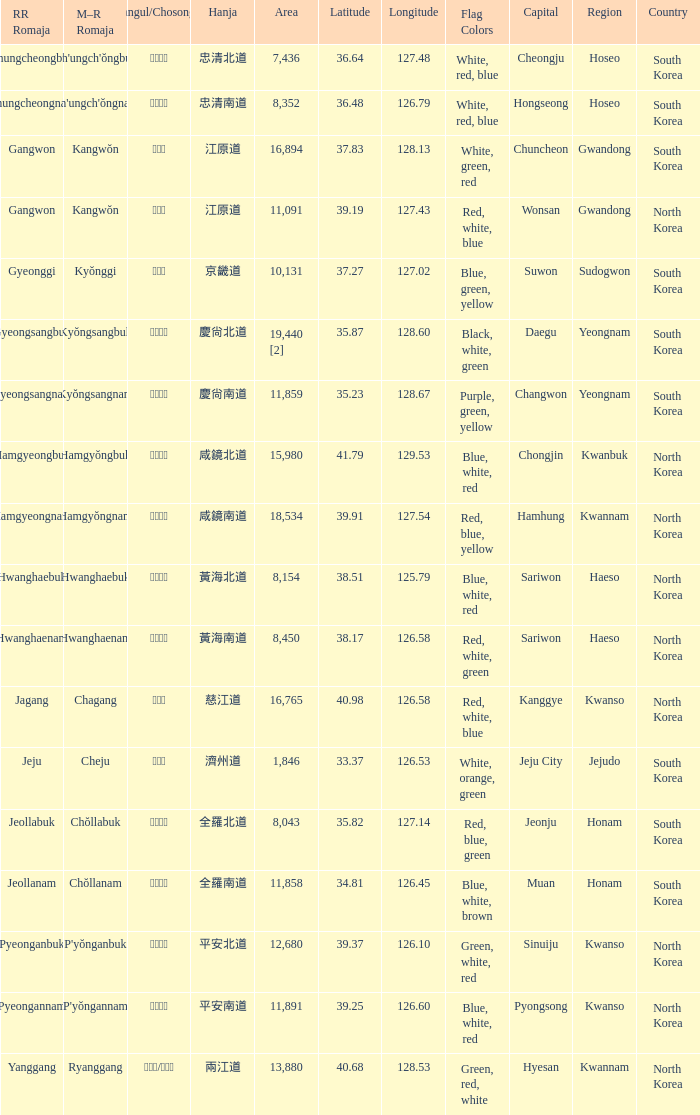Which capital has a Hangul of 경상남도? Changwon. 